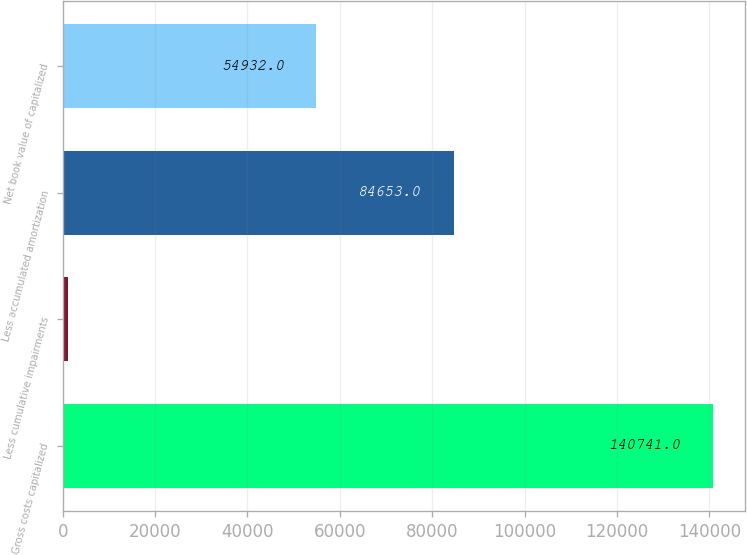<chart> <loc_0><loc_0><loc_500><loc_500><bar_chart><fcel>Gross costs capitalized<fcel>Less cumulative impairments<fcel>Less accumulated amortization<fcel>Net book value of capitalized<nl><fcel>140741<fcel>1156<fcel>84653<fcel>54932<nl></chart> 